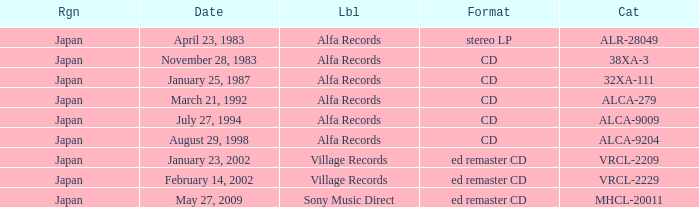Which catalog is in cd format? 38XA-3, 32XA-111, ALCA-279, ALCA-9009, ALCA-9204. 